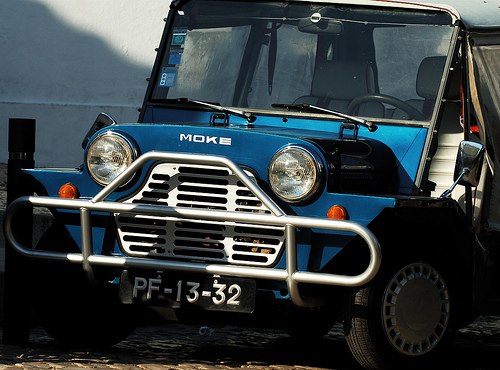<image>
Is there a mirror in front of the rim? No. The mirror is not in front of the rim. The spatial positioning shows a different relationship between these objects. 